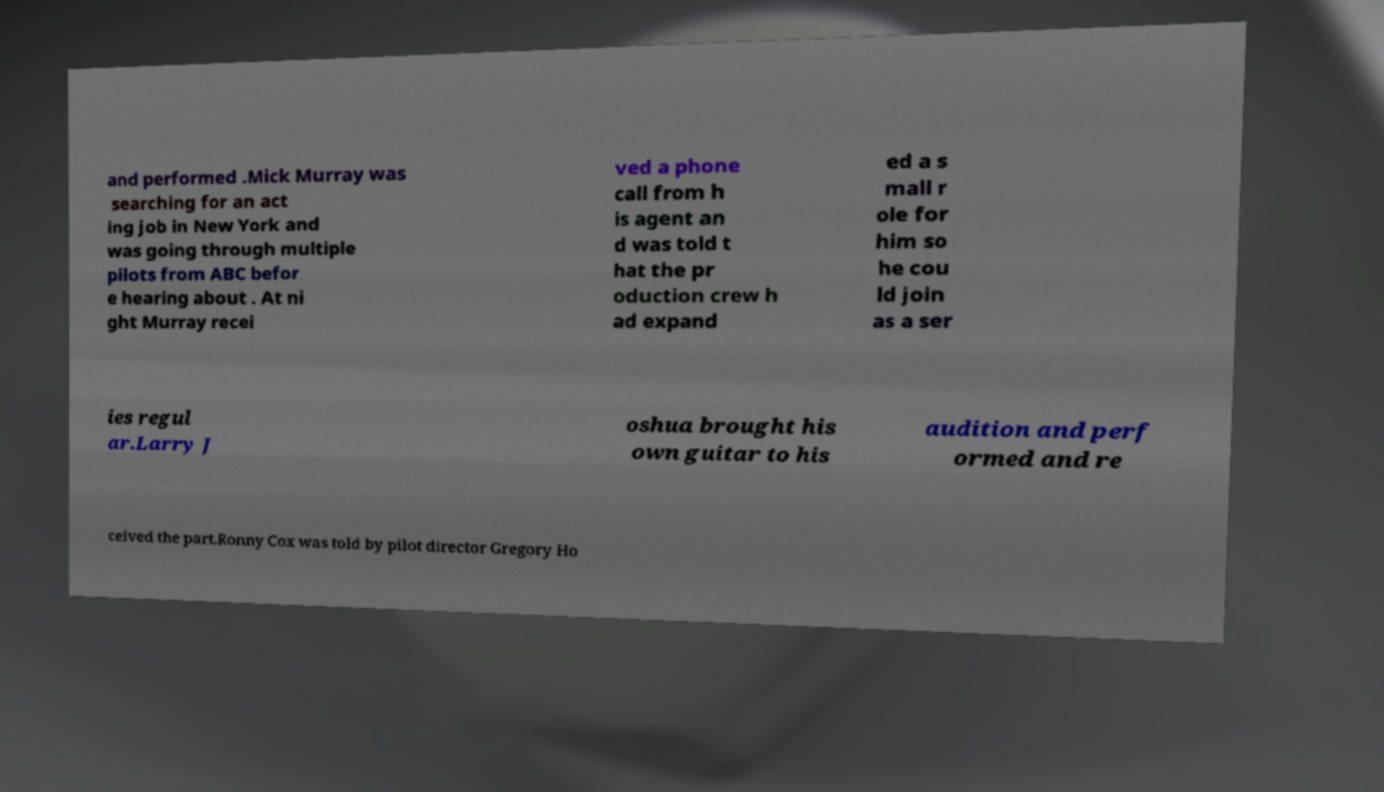There's text embedded in this image that I need extracted. Can you transcribe it verbatim? and performed .Mick Murray was searching for an act ing job in New York and was going through multiple pilots from ABC befor e hearing about . At ni ght Murray recei ved a phone call from h is agent an d was told t hat the pr oduction crew h ad expand ed a s mall r ole for him so he cou ld join as a ser ies regul ar.Larry J oshua brought his own guitar to his audition and perf ormed and re ceived the part.Ronny Cox was told by pilot director Gregory Ho 